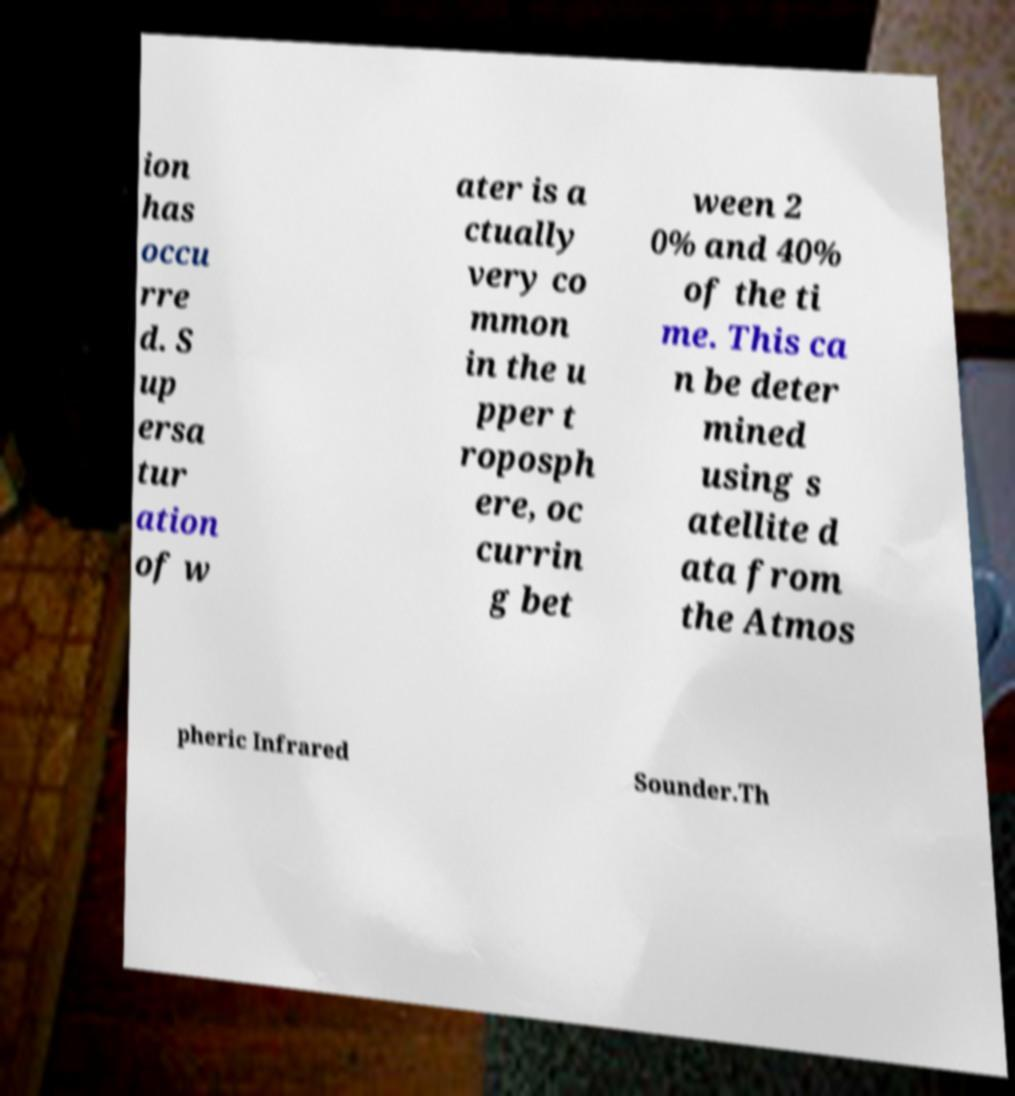Could you extract and type out the text from this image? ion has occu rre d. S up ersa tur ation of w ater is a ctually very co mmon in the u pper t roposph ere, oc currin g bet ween 2 0% and 40% of the ti me. This ca n be deter mined using s atellite d ata from the Atmos pheric Infrared Sounder.Th 